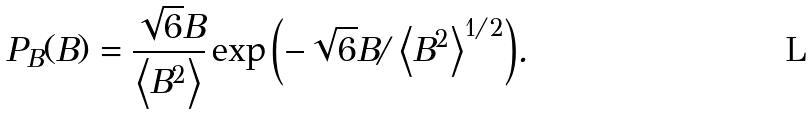Convert formula to latex. <formula><loc_0><loc_0><loc_500><loc_500>P _ { B } ( B ) = \frac { \sqrt { 6 } B } { \left < B ^ { 2 } \right > } \exp { \left ( - \sqrt { 6 } B / \left < B ^ { 2 } \right > ^ { 1 / 2 } \right ) } .</formula> 